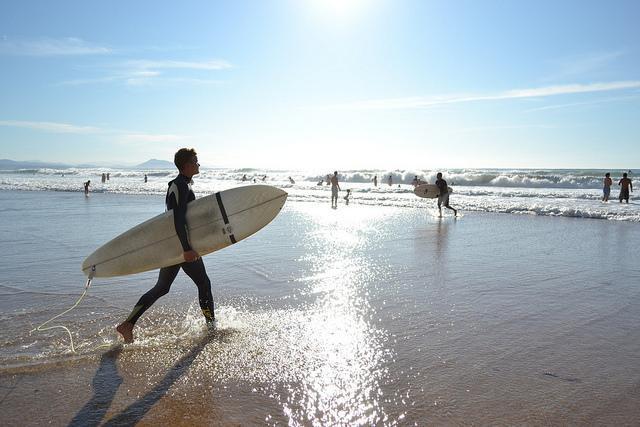How many surfers are visible in the image?
Give a very brief answer. 2. How many people are there?
Give a very brief answer. 1. How many legs is the bear standing on?
Give a very brief answer. 0. 